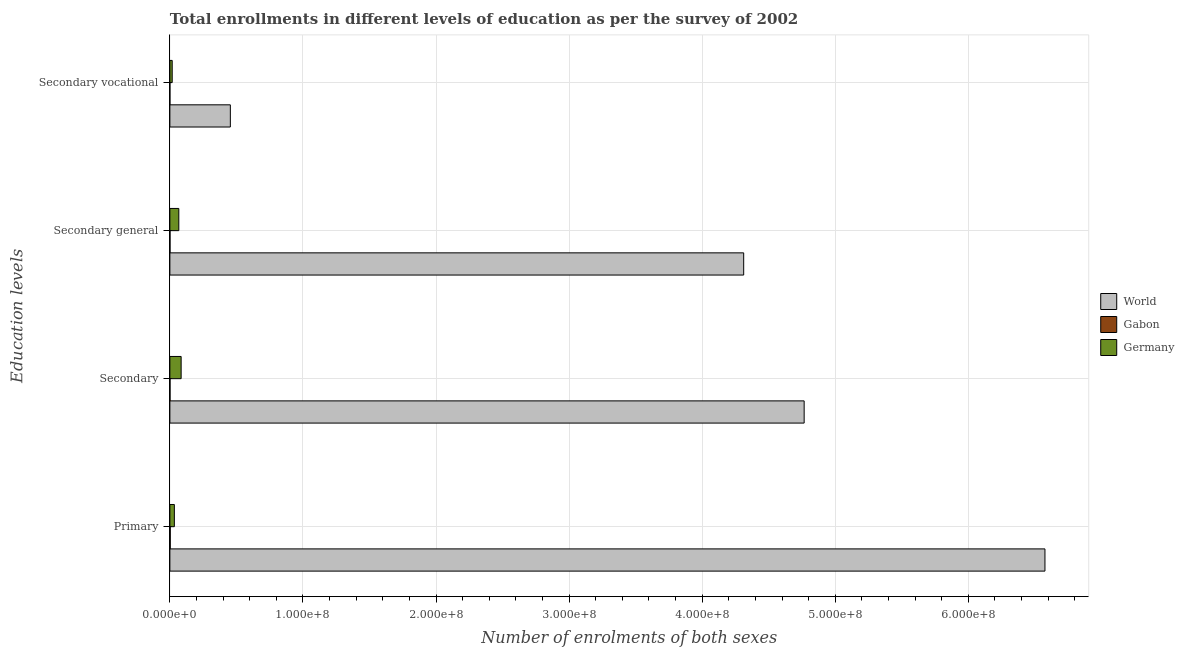How many different coloured bars are there?
Offer a terse response. 3. Are the number of bars on each tick of the Y-axis equal?
Your response must be concise. Yes. How many bars are there on the 1st tick from the top?
Offer a terse response. 3. What is the label of the 4th group of bars from the top?
Offer a terse response. Primary. What is the number of enrolments in secondary general education in World?
Keep it short and to the point. 4.31e+08. Across all countries, what is the maximum number of enrolments in secondary education?
Provide a succinct answer. 4.77e+08. Across all countries, what is the minimum number of enrolments in secondary education?
Your answer should be very brief. 1.05e+05. In which country was the number of enrolments in secondary education maximum?
Ensure brevity in your answer.  World. In which country was the number of enrolments in primary education minimum?
Ensure brevity in your answer.  Gabon. What is the total number of enrolments in secondary education in the graph?
Give a very brief answer. 4.85e+08. What is the difference between the number of enrolments in secondary vocational education in Gabon and that in World?
Your answer should be very brief. -4.54e+07. What is the difference between the number of enrolments in secondary education in Germany and the number of enrolments in secondary general education in World?
Offer a very short reply. -4.23e+08. What is the average number of enrolments in primary education per country?
Make the answer very short. 2.20e+08. What is the difference between the number of enrolments in secondary vocational education and number of enrolments in secondary education in Germany?
Your response must be concise. -6.71e+06. What is the ratio of the number of enrolments in primary education in Gabon to that in World?
Make the answer very short. 0. What is the difference between the highest and the second highest number of enrolments in primary education?
Ensure brevity in your answer.  6.54e+08. What is the difference between the highest and the lowest number of enrolments in secondary education?
Your response must be concise. 4.77e+08. In how many countries, is the number of enrolments in primary education greater than the average number of enrolments in primary education taken over all countries?
Make the answer very short. 1. Is it the case that in every country, the sum of the number of enrolments in secondary education and number of enrolments in secondary general education is greater than the sum of number of enrolments in primary education and number of enrolments in secondary vocational education?
Offer a very short reply. No. What does the 1st bar from the top in Secondary represents?
Offer a terse response. Germany. What does the 2nd bar from the bottom in Secondary general represents?
Provide a short and direct response. Gabon. How many bars are there?
Provide a succinct answer. 12. What is the title of the graph?
Your response must be concise. Total enrollments in different levels of education as per the survey of 2002. What is the label or title of the X-axis?
Keep it short and to the point. Number of enrolments of both sexes. What is the label or title of the Y-axis?
Give a very brief answer. Education levels. What is the Number of enrolments of both sexes of World in Primary?
Your response must be concise. 6.58e+08. What is the Number of enrolments of both sexes of Gabon in Primary?
Make the answer very short. 2.82e+05. What is the Number of enrolments of both sexes of Germany in Primary?
Your response must be concise. 3.37e+06. What is the Number of enrolments of both sexes in World in Secondary?
Offer a terse response. 4.77e+08. What is the Number of enrolments of both sexes of Gabon in Secondary?
Give a very brief answer. 1.05e+05. What is the Number of enrolments of both sexes of Germany in Secondary?
Your response must be concise. 8.47e+06. What is the Number of enrolments of both sexes in World in Secondary general?
Offer a terse response. 4.31e+08. What is the Number of enrolments of both sexes in Gabon in Secondary general?
Ensure brevity in your answer.  9.76e+04. What is the Number of enrolments of both sexes of Germany in Secondary general?
Offer a very short reply. 6.71e+06. What is the Number of enrolments of both sexes in World in Secondary vocational?
Give a very brief answer. 4.54e+07. What is the Number of enrolments of both sexes of Gabon in Secondary vocational?
Offer a very short reply. 7587. What is the Number of enrolments of both sexes in Germany in Secondary vocational?
Make the answer very short. 1.75e+06. Across all Education levels, what is the maximum Number of enrolments of both sexes of World?
Keep it short and to the point. 6.58e+08. Across all Education levels, what is the maximum Number of enrolments of both sexes in Gabon?
Your answer should be very brief. 2.82e+05. Across all Education levels, what is the maximum Number of enrolments of both sexes of Germany?
Make the answer very short. 8.47e+06. Across all Education levels, what is the minimum Number of enrolments of both sexes of World?
Provide a short and direct response. 4.54e+07. Across all Education levels, what is the minimum Number of enrolments of both sexes of Gabon?
Offer a very short reply. 7587. Across all Education levels, what is the minimum Number of enrolments of both sexes of Germany?
Offer a very short reply. 1.75e+06. What is the total Number of enrolments of both sexes of World in the graph?
Ensure brevity in your answer.  1.61e+09. What is the total Number of enrolments of both sexes in Gabon in the graph?
Provide a short and direct response. 4.92e+05. What is the total Number of enrolments of both sexes in Germany in the graph?
Keep it short and to the point. 2.03e+07. What is the difference between the Number of enrolments of both sexes of World in Primary and that in Secondary?
Your answer should be very brief. 1.81e+08. What is the difference between the Number of enrolments of both sexes in Gabon in Primary and that in Secondary?
Your answer should be compact. 1.77e+05. What is the difference between the Number of enrolments of both sexes of Germany in Primary and that in Secondary?
Your answer should be very brief. -5.09e+06. What is the difference between the Number of enrolments of both sexes of World in Primary and that in Secondary general?
Provide a short and direct response. 2.26e+08. What is the difference between the Number of enrolments of both sexes in Gabon in Primary and that in Secondary general?
Make the answer very short. 1.84e+05. What is the difference between the Number of enrolments of both sexes in Germany in Primary and that in Secondary general?
Offer a very short reply. -3.34e+06. What is the difference between the Number of enrolments of both sexes in World in Primary and that in Secondary vocational?
Ensure brevity in your answer.  6.12e+08. What is the difference between the Number of enrolments of both sexes of Gabon in Primary and that in Secondary vocational?
Ensure brevity in your answer.  2.74e+05. What is the difference between the Number of enrolments of both sexes in Germany in Primary and that in Secondary vocational?
Make the answer very short. 1.62e+06. What is the difference between the Number of enrolments of both sexes of World in Secondary and that in Secondary general?
Provide a short and direct response. 4.54e+07. What is the difference between the Number of enrolments of both sexes of Gabon in Secondary and that in Secondary general?
Make the answer very short. 7587. What is the difference between the Number of enrolments of both sexes in Germany in Secondary and that in Secondary general?
Give a very brief answer. 1.75e+06. What is the difference between the Number of enrolments of both sexes of World in Secondary and that in Secondary vocational?
Your answer should be compact. 4.31e+08. What is the difference between the Number of enrolments of both sexes in Gabon in Secondary and that in Secondary vocational?
Keep it short and to the point. 9.76e+04. What is the difference between the Number of enrolments of both sexes in Germany in Secondary and that in Secondary vocational?
Make the answer very short. 6.71e+06. What is the difference between the Number of enrolments of both sexes of World in Secondary general and that in Secondary vocational?
Keep it short and to the point. 3.86e+08. What is the difference between the Number of enrolments of both sexes of Gabon in Secondary general and that in Secondary vocational?
Provide a succinct answer. 9.00e+04. What is the difference between the Number of enrolments of both sexes in Germany in Secondary general and that in Secondary vocational?
Your answer should be compact. 4.96e+06. What is the difference between the Number of enrolments of both sexes in World in Primary and the Number of enrolments of both sexes in Gabon in Secondary?
Your answer should be compact. 6.57e+08. What is the difference between the Number of enrolments of both sexes of World in Primary and the Number of enrolments of both sexes of Germany in Secondary?
Offer a terse response. 6.49e+08. What is the difference between the Number of enrolments of both sexes of Gabon in Primary and the Number of enrolments of both sexes of Germany in Secondary?
Your answer should be very brief. -8.18e+06. What is the difference between the Number of enrolments of both sexes in World in Primary and the Number of enrolments of both sexes in Gabon in Secondary general?
Provide a succinct answer. 6.58e+08. What is the difference between the Number of enrolments of both sexes of World in Primary and the Number of enrolments of both sexes of Germany in Secondary general?
Ensure brevity in your answer.  6.51e+08. What is the difference between the Number of enrolments of both sexes in Gabon in Primary and the Number of enrolments of both sexes in Germany in Secondary general?
Ensure brevity in your answer.  -6.43e+06. What is the difference between the Number of enrolments of both sexes in World in Primary and the Number of enrolments of both sexes in Gabon in Secondary vocational?
Provide a succinct answer. 6.58e+08. What is the difference between the Number of enrolments of both sexes of World in Primary and the Number of enrolments of both sexes of Germany in Secondary vocational?
Your response must be concise. 6.56e+08. What is the difference between the Number of enrolments of both sexes of Gabon in Primary and the Number of enrolments of both sexes of Germany in Secondary vocational?
Offer a terse response. -1.47e+06. What is the difference between the Number of enrolments of both sexes in World in Secondary and the Number of enrolments of both sexes in Gabon in Secondary general?
Provide a succinct answer. 4.77e+08. What is the difference between the Number of enrolments of both sexes in World in Secondary and the Number of enrolments of both sexes in Germany in Secondary general?
Provide a succinct answer. 4.70e+08. What is the difference between the Number of enrolments of both sexes in Gabon in Secondary and the Number of enrolments of both sexes in Germany in Secondary general?
Give a very brief answer. -6.61e+06. What is the difference between the Number of enrolments of both sexes of World in Secondary and the Number of enrolments of both sexes of Gabon in Secondary vocational?
Offer a terse response. 4.77e+08. What is the difference between the Number of enrolments of both sexes in World in Secondary and the Number of enrolments of both sexes in Germany in Secondary vocational?
Offer a very short reply. 4.75e+08. What is the difference between the Number of enrolments of both sexes of Gabon in Secondary and the Number of enrolments of both sexes of Germany in Secondary vocational?
Give a very brief answer. -1.65e+06. What is the difference between the Number of enrolments of both sexes in World in Secondary general and the Number of enrolments of both sexes in Gabon in Secondary vocational?
Offer a very short reply. 4.31e+08. What is the difference between the Number of enrolments of both sexes of World in Secondary general and the Number of enrolments of both sexes of Germany in Secondary vocational?
Offer a very short reply. 4.29e+08. What is the difference between the Number of enrolments of both sexes of Gabon in Secondary general and the Number of enrolments of both sexes of Germany in Secondary vocational?
Offer a very short reply. -1.66e+06. What is the average Number of enrolments of both sexes in World per Education levels?
Offer a very short reply. 4.03e+08. What is the average Number of enrolments of both sexes in Gabon per Education levels?
Offer a terse response. 1.23e+05. What is the average Number of enrolments of both sexes of Germany per Education levels?
Provide a short and direct response. 5.08e+06. What is the difference between the Number of enrolments of both sexes of World and Number of enrolments of both sexes of Gabon in Primary?
Offer a very short reply. 6.57e+08. What is the difference between the Number of enrolments of both sexes of World and Number of enrolments of both sexes of Germany in Primary?
Offer a very short reply. 6.54e+08. What is the difference between the Number of enrolments of both sexes in Gabon and Number of enrolments of both sexes in Germany in Primary?
Make the answer very short. -3.09e+06. What is the difference between the Number of enrolments of both sexes in World and Number of enrolments of both sexes in Gabon in Secondary?
Provide a short and direct response. 4.77e+08. What is the difference between the Number of enrolments of both sexes in World and Number of enrolments of both sexes in Germany in Secondary?
Offer a terse response. 4.68e+08. What is the difference between the Number of enrolments of both sexes of Gabon and Number of enrolments of both sexes of Germany in Secondary?
Your answer should be compact. -8.36e+06. What is the difference between the Number of enrolments of both sexes of World and Number of enrolments of both sexes of Gabon in Secondary general?
Your response must be concise. 4.31e+08. What is the difference between the Number of enrolments of both sexes of World and Number of enrolments of both sexes of Germany in Secondary general?
Your answer should be very brief. 4.24e+08. What is the difference between the Number of enrolments of both sexes of Gabon and Number of enrolments of both sexes of Germany in Secondary general?
Your answer should be very brief. -6.61e+06. What is the difference between the Number of enrolments of both sexes of World and Number of enrolments of both sexes of Gabon in Secondary vocational?
Offer a terse response. 4.54e+07. What is the difference between the Number of enrolments of both sexes of World and Number of enrolments of both sexes of Germany in Secondary vocational?
Your answer should be very brief. 4.37e+07. What is the difference between the Number of enrolments of both sexes of Gabon and Number of enrolments of both sexes of Germany in Secondary vocational?
Your response must be concise. -1.75e+06. What is the ratio of the Number of enrolments of both sexes in World in Primary to that in Secondary?
Make the answer very short. 1.38. What is the ratio of the Number of enrolments of both sexes of Gabon in Primary to that in Secondary?
Provide a succinct answer. 2.68. What is the ratio of the Number of enrolments of both sexes of Germany in Primary to that in Secondary?
Offer a very short reply. 0.4. What is the ratio of the Number of enrolments of both sexes in World in Primary to that in Secondary general?
Your response must be concise. 1.52. What is the ratio of the Number of enrolments of both sexes in Gabon in Primary to that in Secondary general?
Ensure brevity in your answer.  2.89. What is the ratio of the Number of enrolments of both sexes of Germany in Primary to that in Secondary general?
Your answer should be very brief. 0.5. What is the ratio of the Number of enrolments of both sexes in World in Primary to that in Secondary vocational?
Give a very brief answer. 14.47. What is the ratio of the Number of enrolments of both sexes in Gabon in Primary to that in Secondary vocational?
Offer a very short reply. 37.15. What is the ratio of the Number of enrolments of both sexes of Germany in Primary to that in Secondary vocational?
Offer a terse response. 1.92. What is the ratio of the Number of enrolments of both sexes of World in Secondary to that in Secondary general?
Offer a very short reply. 1.11. What is the ratio of the Number of enrolments of both sexes of Gabon in Secondary to that in Secondary general?
Your answer should be compact. 1.08. What is the ratio of the Number of enrolments of both sexes of Germany in Secondary to that in Secondary general?
Your answer should be very brief. 1.26. What is the ratio of the Number of enrolments of both sexes of World in Secondary to that in Secondary vocational?
Your response must be concise. 10.49. What is the ratio of the Number of enrolments of both sexes of Gabon in Secondary to that in Secondary vocational?
Your answer should be very brief. 13.86. What is the ratio of the Number of enrolments of both sexes of Germany in Secondary to that in Secondary vocational?
Make the answer very short. 4.83. What is the ratio of the Number of enrolments of both sexes in World in Secondary general to that in Secondary vocational?
Your response must be concise. 9.49. What is the ratio of the Number of enrolments of both sexes of Gabon in Secondary general to that in Secondary vocational?
Provide a short and direct response. 12.86. What is the ratio of the Number of enrolments of both sexes in Germany in Secondary general to that in Secondary vocational?
Offer a very short reply. 3.83. What is the difference between the highest and the second highest Number of enrolments of both sexes of World?
Provide a succinct answer. 1.81e+08. What is the difference between the highest and the second highest Number of enrolments of both sexes in Gabon?
Give a very brief answer. 1.77e+05. What is the difference between the highest and the second highest Number of enrolments of both sexes of Germany?
Offer a terse response. 1.75e+06. What is the difference between the highest and the lowest Number of enrolments of both sexes in World?
Give a very brief answer. 6.12e+08. What is the difference between the highest and the lowest Number of enrolments of both sexes in Gabon?
Your response must be concise. 2.74e+05. What is the difference between the highest and the lowest Number of enrolments of both sexes in Germany?
Give a very brief answer. 6.71e+06. 